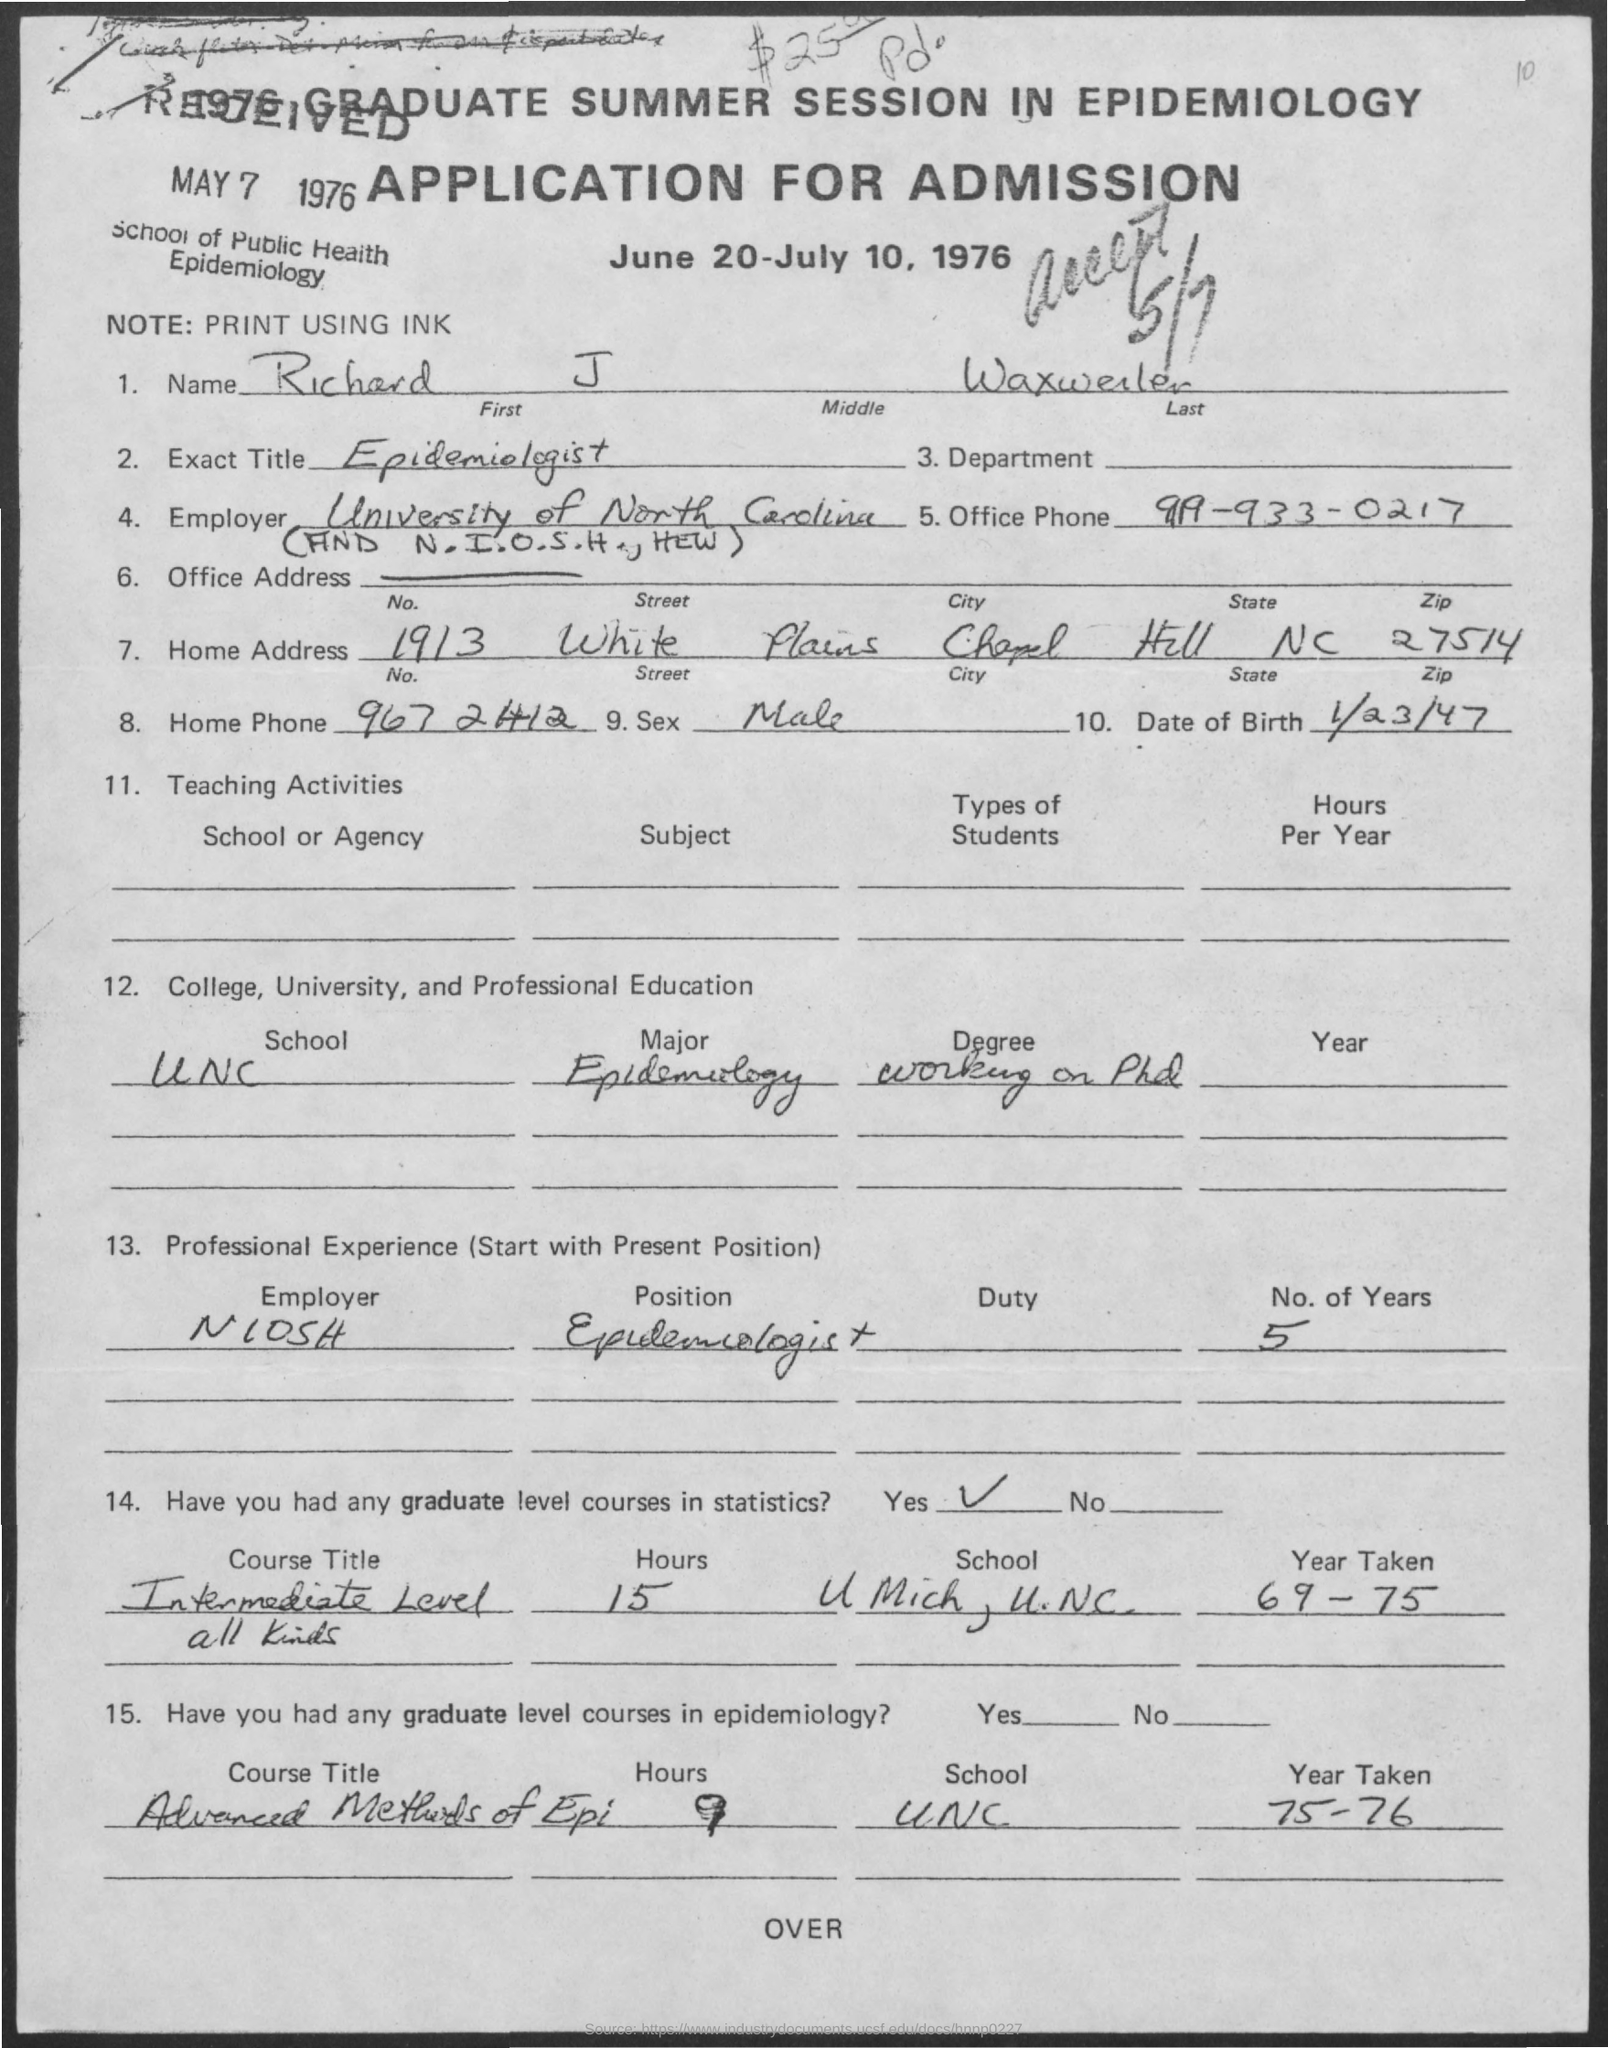Specify some key components in this picture. What is sex? Male genitalia are complex structures that serve both reproductive and sexual functions. The applicant's date of birth is January 23, 1947. 